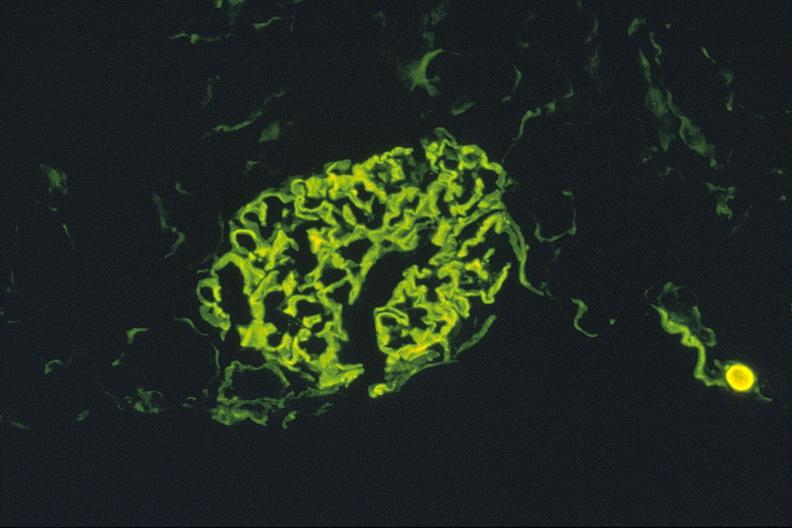what does this image show?
Answer the question using a single word or phrase. Antiglomerlar basement membrane 